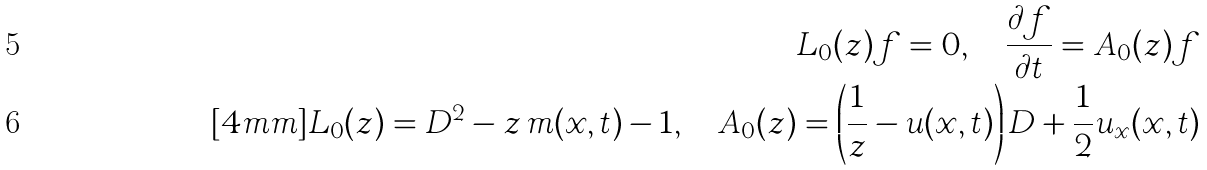Convert formula to latex. <formula><loc_0><loc_0><loc_500><loc_500>L _ { 0 } ( z ) f = 0 , \quad \frac { \partial f } { \partial t } = A _ { 0 } ( z ) f \\ [ 4 m m ] L _ { 0 } ( z ) = D ^ { 2 } - z \, m ( x , t ) - 1 , \quad A _ { 0 } ( z ) = \left ( \frac { 1 } { z } - u ( x , t ) \right ) D + \frac { 1 } { 2 } u _ { x } ( x , t )</formula> 